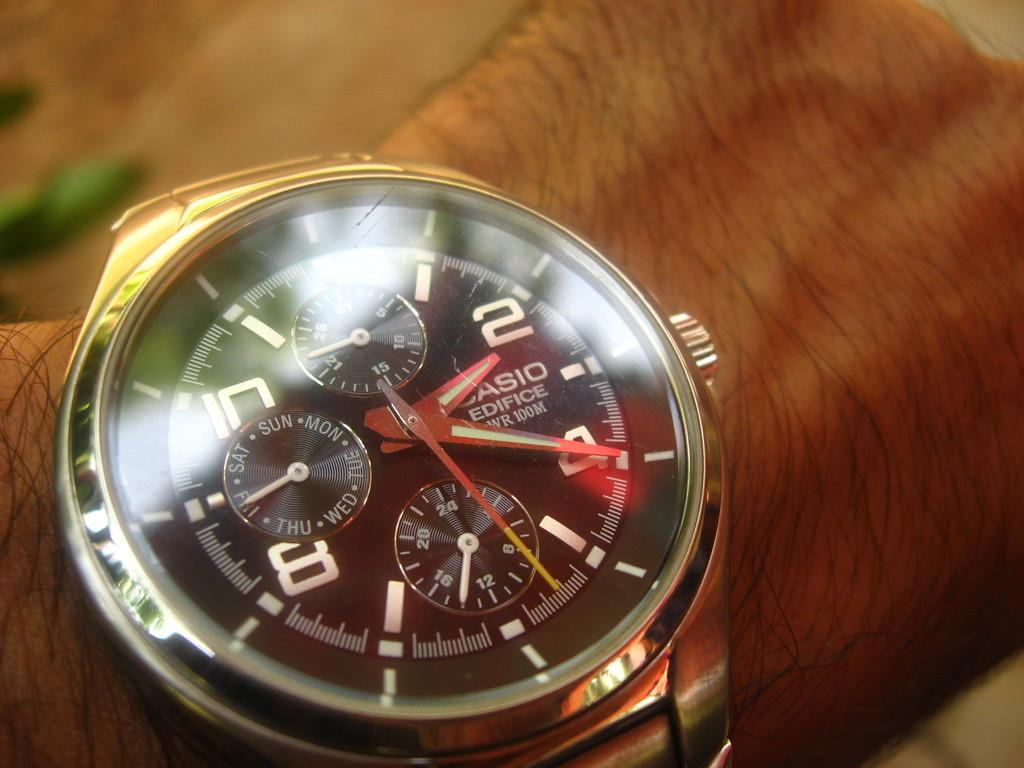<image>
Render a clear and concise summary of the photo. A person wears a Casio Edifice watch that says the time is 2:20. 